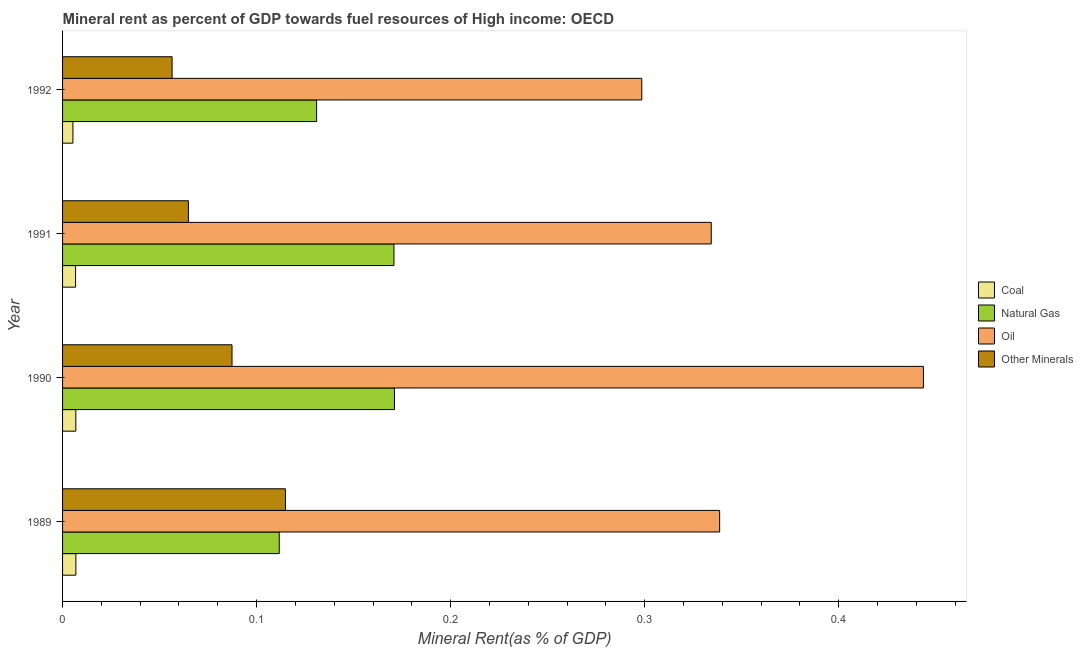How many groups of bars are there?
Offer a very short reply. 4. Are the number of bars per tick equal to the number of legend labels?
Ensure brevity in your answer.  Yes. How many bars are there on the 2nd tick from the bottom?
Provide a succinct answer. 4. What is the label of the 3rd group of bars from the top?
Offer a terse response. 1990. What is the coal rent in 1989?
Your answer should be very brief. 0.01. Across all years, what is the maximum oil rent?
Offer a very short reply. 0.44. Across all years, what is the minimum  rent of other minerals?
Your response must be concise. 0.06. In which year was the  rent of other minerals minimum?
Give a very brief answer. 1992. What is the total natural gas rent in the graph?
Give a very brief answer. 0.58. What is the difference between the  rent of other minerals in 1989 and that in 1990?
Your answer should be very brief. 0.03. What is the difference between the natural gas rent in 1991 and the coal rent in 1990?
Offer a very short reply. 0.16. What is the average  rent of other minerals per year?
Offer a terse response. 0.08. In the year 1990, what is the difference between the coal rent and  rent of other minerals?
Offer a very short reply. -0.08. In how many years, is the coal rent greater than 0.36000000000000004 %?
Keep it short and to the point. 0. What is the ratio of the oil rent in 1990 to that in 1992?
Keep it short and to the point. 1.49. Is the difference between the oil rent in 1989 and 1991 greater than the difference between the  rent of other minerals in 1989 and 1991?
Give a very brief answer. No. What is the difference between the highest and the second highest  rent of other minerals?
Provide a succinct answer. 0.03. What is the difference between the highest and the lowest oil rent?
Your answer should be compact. 0.15. Is the sum of the coal rent in 1990 and 1992 greater than the maximum natural gas rent across all years?
Your answer should be compact. No. What does the 3rd bar from the top in 1989 represents?
Keep it short and to the point. Natural Gas. What does the 2nd bar from the bottom in 1992 represents?
Your answer should be very brief. Natural Gas. Is it the case that in every year, the sum of the coal rent and natural gas rent is greater than the oil rent?
Provide a succinct answer. No. How many bars are there?
Provide a short and direct response. 16. Are the values on the major ticks of X-axis written in scientific E-notation?
Make the answer very short. No. Does the graph contain any zero values?
Provide a succinct answer. No. How many legend labels are there?
Make the answer very short. 4. What is the title of the graph?
Your response must be concise. Mineral rent as percent of GDP towards fuel resources of High income: OECD. What is the label or title of the X-axis?
Offer a terse response. Mineral Rent(as % of GDP). What is the label or title of the Y-axis?
Offer a very short reply. Year. What is the Mineral Rent(as % of GDP) in Coal in 1989?
Offer a terse response. 0.01. What is the Mineral Rent(as % of GDP) in Natural Gas in 1989?
Provide a succinct answer. 0.11. What is the Mineral Rent(as % of GDP) in Oil in 1989?
Your answer should be very brief. 0.34. What is the Mineral Rent(as % of GDP) of Other Minerals in 1989?
Keep it short and to the point. 0.11. What is the Mineral Rent(as % of GDP) in Coal in 1990?
Offer a terse response. 0.01. What is the Mineral Rent(as % of GDP) of Natural Gas in 1990?
Make the answer very short. 0.17. What is the Mineral Rent(as % of GDP) of Oil in 1990?
Your answer should be very brief. 0.44. What is the Mineral Rent(as % of GDP) in Other Minerals in 1990?
Give a very brief answer. 0.09. What is the Mineral Rent(as % of GDP) of Coal in 1991?
Give a very brief answer. 0.01. What is the Mineral Rent(as % of GDP) of Natural Gas in 1991?
Provide a short and direct response. 0.17. What is the Mineral Rent(as % of GDP) in Oil in 1991?
Provide a short and direct response. 0.33. What is the Mineral Rent(as % of GDP) of Other Minerals in 1991?
Provide a short and direct response. 0.06. What is the Mineral Rent(as % of GDP) of Coal in 1992?
Keep it short and to the point. 0.01. What is the Mineral Rent(as % of GDP) in Natural Gas in 1992?
Give a very brief answer. 0.13. What is the Mineral Rent(as % of GDP) of Oil in 1992?
Make the answer very short. 0.3. What is the Mineral Rent(as % of GDP) of Other Minerals in 1992?
Provide a succinct answer. 0.06. Across all years, what is the maximum Mineral Rent(as % of GDP) of Coal?
Ensure brevity in your answer.  0.01. Across all years, what is the maximum Mineral Rent(as % of GDP) of Natural Gas?
Offer a terse response. 0.17. Across all years, what is the maximum Mineral Rent(as % of GDP) in Oil?
Keep it short and to the point. 0.44. Across all years, what is the maximum Mineral Rent(as % of GDP) of Other Minerals?
Your response must be concise. 0.11. Across all years, what is the minimum Mineral Rent(as % of GDP) of Coal?
Make the answer very short. 0.01. Across all years, what is the minimum Mineral Rent(as % of GDP) of Natural Gas?
Provide a short and direct response. 0.11. Across all years, what is the minimum Mineral Rent(as % of GDP) of Oil?
Keep it short and to the point. 0.3. Across all years, what is the minimum Mineral Rent(as % of GDP) in Other Minerals?
Your answer should be very brief. 0.06. What is the total Mineral Rent(as % of GDP) in Coal in the graph?
Provide a short and direct response. 0.03. What is the total Mineral Rent(as % of GDP) in Natural Gas in the graph?
Make the answer very short. 0.58. What is the total Mineral Rent(as % of GDP) of Oil in the graph?
Give a very brief answer. 1.42. What is the total Mineral Rent(as % of GDP) in Other Minerals in the graph?
Your answer should be compact. 0.32. What is the difference between the Mineral Rent(as % of GDP) of Natural Gas in 1989 and that in 1990?
Offer a very short reply. -0.06. What is the difference between the Mineral Rent(as % of GDP) in Oil in 1989 and that in 1990?
Your response must be concise. -0.1. What is the difference between the Mineral Rent(as % of GDP) of Other Minerals in 1989 and that in 1990?
Provide a short and direct response. 0.03. What is the difference between the Mineral Rent(as % of GDP) of Natural Gas in 1989 and that in 1991?
Your response must be concise. -0.06. What is the difference between the Mineral Rent(as % of GDP) in Oil in 1989 and that in 1991?
Provide a succinct answer. 0. What is the difference between the Mineral Rent(as % of GDP) of Other Minerals in 1989 and that in 1991?
Ensure brevity in your answer.  0.05. What is the difference between the Mineral Rent(as % of GDP) in Coal in 1989 and that in 1992?
Your answer should be very brief. 0. What is the difference between the Mineral Rent(as % of GDP) in Natural Gas in 1989 and that in 1992?
Your answer should be compact. -0.02. What is the difference between the Mineral Rent(as % of GDP) in Oil in 1989 and that in 1992?
Give a very brief answer. 0.04. What is the difference between the Mineral Rent(as % of GDP) of Other Minerals in 1989 and that in 1992?
Make the answer very short. 0.06. What is the difference between the Mineral Rent(as % of GDP) in Natural Gas in 1990 and that in 1991?
Your response must be concise. 0. What is the difference between the Mineral Rent(as % of GDP) in Oil in 1990 and that in 1991?
Make the answer very short. 0.11. What is the difference between the Mineral Rent(as % of GDP) in Other Minerals in 1990 and that in 1991?
Give a very brief answer. 0.02. What is the difference between the Mineral Rent(as % of GDP) of Coal in 1990 and that in 1992?
Give a very brief answer. 0. What is the difference between the Mineral Rent(as % of GDP) of Natural Gas in 1990 and that in 1992?
Offer a terse response. 0.04. What is the difference between the Mineral Rent(as % of GDP) in Oil in 1990 and that in 1992?
Your response must be concise. 0.15. What is the difference between the Mineral Rent(as % of GDP) in Other Minerals in 1990 and that in 1992?
Your answer should be compact. 0.03. What is the difference between the Mineral Rent(as % of GDP) of Coal in 1991 and that in 1992?
Give a very brief answer. 0. What is the difference between the Mineral Rent(as % of GDP) in Natural Gas in 1991 and that in 1992?
Ensure brevity in your answer.  0.04. What is the difference between the Mineral Rent(as % of GDP) of Oil in 1991 and that in 1992?
Offer a terse response. 0.04. What is the difference between the Mineral Rent(as % of GDP) of Other Minerals in 1991 and that in 1992?
Your answer should be very brief. 0.01. What is the difference between the Mineral Rent(as % of GDP) of Coal in 1989 and the Mineral Rent(as % of GDP) of Natural Gas in 1990?
Make the answer very short. -0.16. What is the difference between the Mineral Rent(as % of GDP) in Coal in 1989 and the Mineral Rent(as % of GDP) in Oil in 1990?
Make the answer very short. -0.44. What is the difference between the Mineral Rent(as % of GDP) of Coal in 1989 and the Mineral Rent(as % of GDP) of Other Minerals in 1990?
Ensure brevity in your answer.  -0.08. What is the difference between the Mineral Rent(as % of GDP) in Natural Gas in 1989 and the Mineral Rent(as % of GDP) in Oil in 1990?
Provide a short and direct response. -0.33. What is the difference between the Mineral Rent(as % of GDP) of Natural Gas in 1989 and the Mineral Rent(as % of GDP) of Other Minerals in 1990?
Offer a terse response. 0.02. What is the difference between the Mineral Rent(as % of GDP) in Oil in 1989 and the Mineral Rent(as % of GDP) in Other Minerals in 1990?
Your response must be concise. 0.25. What is the difference between the Mineral Rent(as % of GDP) in Coal in 1989 and the Mineral Rent(as % of GDP) in Natural Gas in 1991?
Make the answer very short. -0.16. What is the difference between the Mineral Rent(as % of GDP) in Coal in 1989 and the Mineral Rent(as % of GDP) in Oil in 1991?
Your response must be concise. -0.33. What is the difference between the Mineral Rent(as % of GDP) in Coal in 1989 and the Mineral Rent(as % of GDP) in Other Minerals in 1991?
Offer a terse response. -0.06. What is the difference between the Mineral Rent(as % of GDP) in Natural Gas in 1989 and the Mineral Rent(as % of GDP) in Oil in 1991?
Your answer should be very brief. -0.22. What is the difference between the Mineral Rent(as % of GDP) of Natural Gas in 1989 and the Mineral Rent(as % of GDP) of Other Minerals in 1991?
Keep it short and to the point. 0.05. What is the difference between the Mineral Rent(as % of GDP) of Oil in 1989 and the Mineral Rent(as % of GDP) of Other Minerals in 1991?
Your answer should be compact. 0.27. What is the difference between the Mineral Rent(as % of GDP) of Coal in 1989 and the Mineral Rent(as % of GDP) of Natural Gas in 1992?
Your answer should be very brief. -0.12. What is the difference between the Mineral Rent(as % of GDP) in Coal in 1989 and the Mineral Rent(as % of GDP) in Oil in 1992?
Your answer should be compact. -0.29. What is the difference between the Mineral Rent(as % of GDP) of Coal in 1989 and the Mineral Rent(as % of GDP) of Other Minerals in 1992?
Provide a succinct answer. -0.05. What is the difference between the Mineral Rent(as % of GDP) in Natural Gas in 1989 and the Mineral Rent(as % of GDP) in Oil in 1992?
Make the answer very short. -0.19. What is the difference between the Mineral Rent(as % of GDP) in Natural Gas in 1989 and the Mineral Rent(as % of GDP) in Other Minerals in 1992?
Offer a terse response. 0.06. What is the difference between the Mineral Rent(as % of GDP) in Oil in 1989 and the Mineral Rent(as % of GDP) in Other Minerals in 1992?
Provide a short and direct response. 0.28. What is the difference between the Mineral Rent(as % of GDP) of Coal in 1990 and the Mineral Rent(as % of GDP) of Natural Gas in 1991?
Your response must be concise. -0.16. What is the difference between the Mineral Rent(as % of GDP) in Coal in 1990 and the Mineral Rent(as % of GDP) in Oil in 1991?
Ensure brevity in your answer.  -0.33. What is the difference between the Mineral Rent(as % of GDP) of Coal in 1990 and the Mineral Rent(as % of GDP) of Other Minerals in 1991?
Your answer should be compact. -0.06. What is the difference between the Mineral Rent(as % of GDP) of Natural Gas in 1990 and the Mineral Rent(as % of GDP) of Oil in 1991?
Offer a terse response. -0.16. What is the difference between the Mineral Rent(as % of GDP) in Natural Gas in 1990 and the Mineral Rent(as % of GDP) in Other Minerals in 1991?
Provide a succinct answer. 0.11. What is the difference between the Mineral Rent(as % of GDP) of Oil in 1990 and the Mineral Rent(as % of GDP) of Other Minerals in 1991?
Ensure brevity in your answer.  0.38. What is the difference between the Mineral Rent(as % of GDP) in Coal in 1990 and the Mineral Rent(as % of GDP) in Natural Gas in 1992?
Your response must be concise. -0.12. What is the difference between the Mineral Rent(as % of GDP) of Coal in 1990 and the Mineral Rent(as % of GDP) of Oil in 1992?
Your answer should be very brief. -0.29. What is the difference between the Mineral Rent(as % of GDP) in Coal in 1990 and the Mineral Rent(as % of GDP) in Other Minerals in 1992?
Your answer should be very brief. -0.05. What is the difference between the Mineral Rent(as % of GDP) of Natural Gas in 1990 and the Mineral Rent(as % of GDP) of Oil in 1992?
Your response must be concise. -0.13. What is the difference between the Mineral Rent(as % of GDP) in Natural Gas in 1990 and the Mineral Rent(as % of GDP) in Other Minerals in 1992?
Ensure brevity in your answer.  0.11. What is the difference between the Mineral Rent(as % of GDP) in Oil in 1990 and the Mineral Rent(as % of GDP) in Other Minerals in 1992?
Give a very brief answer. 0.39. What is the difference between the Mineral Rent(as % of GDP) in Coal in 1991 and the Mineral Rent(as % of GDP) in Natural Gas in 1992?
Offer a very short reply. -0.12. What is the difference between the Mineral Rent(as % of GDP) of Coal in 1991 and the Mineral Rent(as % of GDP) of Oil in 1992?
Ensure brevity in your answer.  -0.29. What is the difference between the Mineral Rent(as % of GDP) of Coal in 1991 and the Mineral Rent(as % of GDP) of Other Minerals in 1992?
Your response must be concise. -0.05. What is the difference between the Mineral Rent(as % of GDP) in Natural Gas in 1991 and the Mineral Rent(as % of GDP) in Oil in 1992?
Your answer should be compact. -0.13. What is the difference between the Mineral Rent(as % of GDP) in Natural Gas in 1991 and the Mineral Rent(as % of GDP) in Other Minerals in 1992?
Offer a very short reply. 0.11. What is the difference between the Mineral Rent(as % of GDP) in Oil in 1991 and the Mineral Rent(as % of GDP) in Other Minerals in 1992?
Your answer should be compact. 0.28. What is the average Mineral Rent(as % of GDP) of Coal per year?
Give a very brief answer. 0.01. What is the average Mineral Rent(as % of GDP) of Natural Gas per year?
Keep it short and to the point. 0.15. What is the average Mineral Rent(as % of GDP) of Oil per year?
Make the answer very short. 0.35. What is the average Mineral Rent(as % of GDP) in Other Minerals per year?
Your response must be concise. 0.08. In the year 1989, what is the difference between the Mineral Rent(as % of GDP) of Coal and Mineral Rent(as % of GDP) of Natural Gas?
Your answer should be very brief. -0.1. In the year 1989, what is the difference between the Mineral Rent(as % of GDP) in Coal and Mineral Rent(as % of GDP) in Oil?
Give a very brief answer. -0.33. In the year 1989, what is the difference between the Mineral Rent(as % of GDP) in Coal and Mineral Rent(as % of GDP) in Other Minerals?
Your answer should be very brief. -0.11. In the year 1989, what is the difference between the Mineral Rent(as % of GDP) in Natural Gas and Mineral Rent(as % of GDP) in Oil?
Your answer should be compact. -0.23. In the year 1989, what is the difference between the Mineral Rent(as % of GDP) of Natural Gas and Mineral Rent(as % of GDP) of Other Minerals?
Keep it short and to the point. -0. In the year 1989, what is the difference between the Mineral Rent(as % of GDP) in Oil and Mineral Rent(as % of GDP) in Other Minerals?
Ensure brevity in your answer.  0.22. In the year 1990, what is the difference between the Mineral Rent(as % of GDP) of Coal and Mineral Rent(as % of GDP) of Natural Gas?
Offer a terse response. -0.16. In the year 1990, what is the difference between the Mineral Rent(as % of GDP) in Coal and Mineral Rent(as % of GDP) in Oil?
Your response must be concise. -0.44. In the year 1990, what is the difference between the Mineral Rent(as % of GDP) in Coal and Mineral Rent(as % of GDP) in Other Minerals?
Provide a succinct answer. -0.08. In the year 1990, what is the difference between the Mineral Rent(as % of GDP) in Natural Gas and Mineral Rent(as % of GDP) in Oil?
Your answer should be compact. -0.27. In the year 1990, what is the difference between the Mineral Rent(as % of GDP) in Natural Gas and Mineral Rent(as % of GDP) in Other Minerals?
Offer a terse response. 0.08. In the year 1990, what is the difference between the Mineral Rent(as % of GDP) of Oil and Mineral Rent(as % of GDP) of Other Minerals?
Offer a terse response. 0.36. In the year 1991, what is the difference between the Mineral Rent(as % of GDP) in Coal and Mineral Rent(as % of GDP) in Natural Gas?
Keep it short and to the point. -0.16. In the year 1991, what is the difference between the Mineral Rent(as % of GDP) of Coal and Mineral Rent(as % of GDP) of Oil?
Ensure brevity in your answer.  -0.33. In the year 1991, what is the difference between the Mineral Rent(as % of GDP) in Coal and Mineral Rent(as % of GDP) in Other Minerals?
Your answer should be compact. -0.06. In the year 1991, what is the difference between the Mineral Rent(as % of GDP) in Natural Gas and Mineral Rent(as % of GDP) in Oil?
Your answer should be very brief. -0.16. In the year 1991, what is the difference between the Mineral Rent(as % of GDP) of Natural Gas and Mineral Rent(as % of GDP) of Other Minerals?
Your response must be concise. 0.11. In the year 1991, what is the difference between the Mineral Rent(as % of GDP) of Oil and Mineral Rent(as % of GDP) of Other Minerals?
Offer a terse response. 0.27. In the year 1992, what is the difference between the Mineral Rent(as % of GDP) in Coal and Mineral Rent(as % of GDP) in Natural Gas?
Your answer should be compact. -0.13. In the year 1992, what is the difference between the Mineral Rent(as % of GDP) of Coal and Mineral Rent(as % of GDP) of Oil?
Offer a very short reply. -0.29. In the year 1992, what is the difference between the Mineral Rent(as % of GDP) of Coal and Mineral Rent(as % of GDP) of Other Minerals?
Offer a terse response. -0.05. In the year 1992, what is the difference between the Mineral Rent(as % of GDP) in Natural Gas and Mineral Rent(as % of GDP) in Oil?
Your response must be concise. -0.17. In the year 1992, what is the difference between the Mineral Rent(as % of GDP) in Natural Gas and Mineral Rent(as % of GDP) in Other Minerals?
Make the answer very short. 0.07. In the year 1992, what is the difference between the Mineral Rent(as % of GDP) in Oil and Mineral Rent(as % of GDP) in Other Minerals?
Provide a short and direct response. 0.24. What is the ratio of the Mineral Rent(as % of GDP) in Natural Gas in 1989 to that in 1990?
Your answer should be compact. 0.65. What is the ratio of the Mineral Rent(as % of GDP) of Oil in 1989 to that in 1990?
Make the answer very short. 0.76. What is the ratio of the Mineral Rent(as % of GDP) of Other Minerals in 1989 to that in 1990?
Provide a short and direct response. 1.32. What is the ratio of the Mineral Rent(as % of GDP) of Coal in 1989 to that in 1991?
Ensure brevity in your answer.  1.02. What is the ratio of the Mineral Rent(as % of GDP) of Natural Gas in 1989 to that in 1991?
Your answer should be compact. 0.65. What is the ratio of the Mineral Rent(as % of GDP) in Oil in 1989 to that in 1991?
Make the answer very short. 1.01. What is the ratio of the Mineral Rent(as % of GDP) of Other Minerals in 1989 to that in 1991?
Your response must be concise. 1.77. What is the ratio of the Mineral Rent(as % of GDP) of Coal in 1989 to that in 1992?
Offer a terse response. 1.29. What is the ratio of the Mineral Rent(as % of GDP) in Natural Gas in 1989 to that in 1992?
Your answer should be compact. 0.85. What is the ratio of the Mineral Rent(as % of GDP) of Oil in 1989 to that in 1992?
Provide a succinct answer. 1.13. What is the ratio of the Mineral Rent(as % of GDP) in Other Minerals in 1989 to that in 1992?
Your answer should be very brief. 2.04. What is the ratio of the Mineral Rent(as % of GDP) in Coal in 1990 to that in 1991?
Offer a terse response. 1.02. What is the ratio of the Mineral Rent(as % of GDP) in Oil in 1990 to that in 1991?
Offer a terse response. 1.33. What is the ratio of the Mineral Rent(as % of GDP) of Other Minerals in 1990 to that in 1991?
Make the answer very short. 1.35. What is the ratio of the Mineral Rent(as % of GDP) of Coal in 1990 to that in 1992?
Your answer should be compact. 1.28. What is the ratio of the Mineral Rent(as % of GDP) of Natural Gas in 1990 to that in 1992?
Provide a succinct answer. 1.31. What is the ratio of the Mineral Rent(as % of GDP) of Oil in 1990 to that in 1992?
Your answer should be very brief. 1.49. What is the ratio of the Mineral Rent(as % of GDP) of Other Minerals in 1990 to that in 1992?
Ensure brevity in your answer.  1.55. What is the ratio of the Mineral Rent(as % of GDP) of Coal in 1991 to that in 1992?
Make the answer very short. 1.26. What is the ratio of the Mineral Rent(as % of GDP) in Natural Gas in 1991 to that in 1992?
Keep it short and to the point. 1.3. What is the ratio of the Mineral Rent(as % of GDP) of Oil in 1991 to that in 1992?
Your response must be concise. 1.12. What is the ratio of the Mineral Rent(as % of GDP) of Other Minerals in 1991 to that in 1992?
Ensure brevity in your answer.  1.15. What is the difference between the highest and the second highest Mineral Rent(as % of GDP) in Oil?
Offer a very short reply. 0.1. What is the difference between the highest and the second highest Mineral Rent(as % of GDP) in Other Minerals?
Your answer should be compact. 0.03. What is the difference between the highest and the lowest Mineral Rent(as % of GDP) of Coal?
Provide a succinct answer. 0. What is the difference between the highest and the lowest Mineral Rent(as % of GDP) in Natural Gas?
Ensure brevity in your answer.  0.06. What is the difference between the highest and the lowest Mineral Rent(as % of GDP) in Oil?
Keep it short and to the point. 0.15. What is the difference between the highest and the lowest Mineral Rent(as % of GDP) in Other Minerals?
Your answer should be very brief. 0.06. 